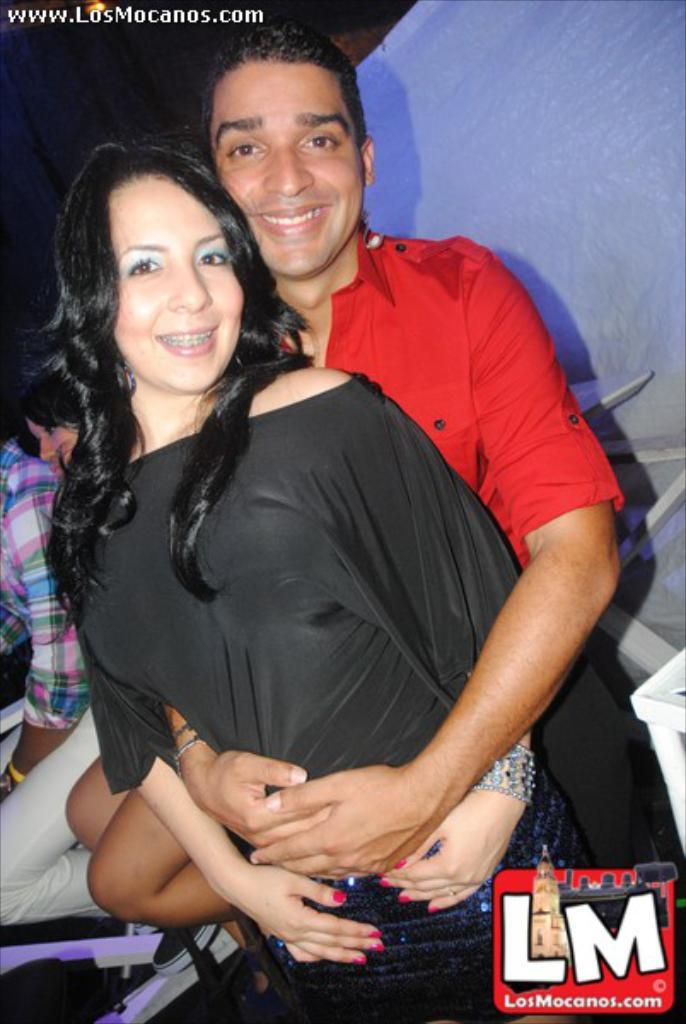How many people are in the image? There are people in the image. Can you describe the clothing of one of the individuals? A woman is wearing a black dress. What is unusual about the clothing of the other person? A man is wearing a red dress. What type of creature is hiding behind the man in the red dress? There is no creature present in the image, and the man in the red dress is not hiding anything. 